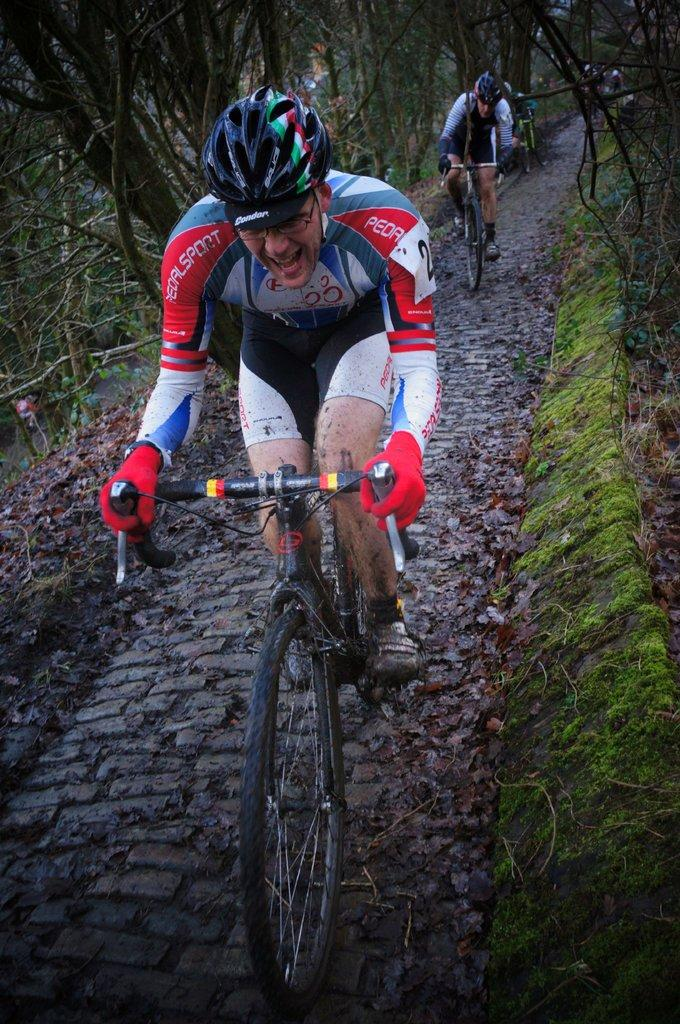How many people are in the image? There are two men in the image. What are the men wearing on their heads? The men are wearing helmets. What activity are the men engaged in? The men are riding bicycles. What type of terrain can be seen in the image? There is ground, trees, and grass visible in the image. What additional detail can be observed on the ground? There are dried leaves on the ground. What time of day is it in the image, based on the position of the sun? The provided facts do not mention the position of the sun or the time of day, so it cannot be determined from the image. What type of sack can be seen being used by the men in the image? There is no sack present in the image. 